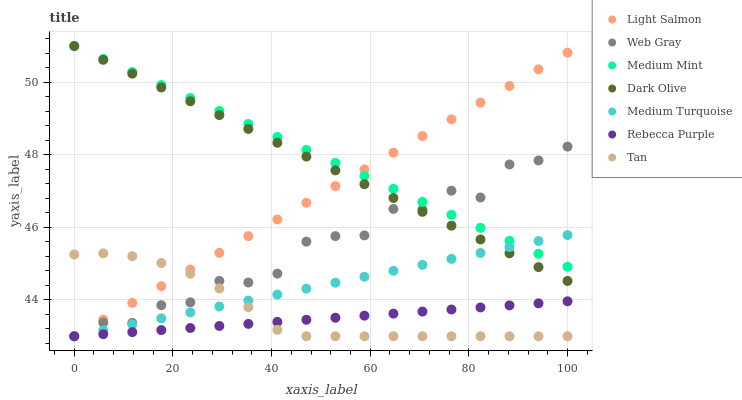Does Rebecca Purple have the minimum area under the curve?
Answer yes or no. Yes. Does Medium Mint have the maximum area under the curve?
Answer yes or no. Yes. Does Light Salmon have the minimum area under the curve?
Answer yes or no. No. Does Light Salmon have the maximum area under the curve?
Answer yes or no. No. Is Light Salmon the smoothest?
Answer yes or no. Yes. Is Web Gray the roughest?
Answer yes or no. Yes. Is Web Gray the smoothest?
Answer yes or no. No. Is Light Salmon the roughest?
Answer yes or no. No. Does Light Salmon have the lowest value?
Answer yes or no. Yes. Does Dark Olive have the lowest value?
Answer yes or no. No. Does Dark Olive have the highest value?
Answer yes or no. Yes. Does Light Salmon have the highest value?
Answer yes or no. No. Is Rebecca Purple less than Medium Mint?
Answer yes or no. Yes. Is Dark Olive greater than Rebecca Purple?
Answer yes or no. Yes. Does Light Salmon intersect Web Gray?
Answer yes or no. Yes. Is Light Salmon less than Web Gray?
Answer yes or no. No. Is Light Salmon greater than Web Gray?
Answer yes or no. No. Does Rebecca Purple intersect Medium Mint?
Answer yes or no. No. 